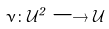<formula> <loc_0><loc_0><loc_500><loc_500>\nu \colon \mathcal { U } ^ { 2 } \longrightarrow \mathcal { U }</formula> 